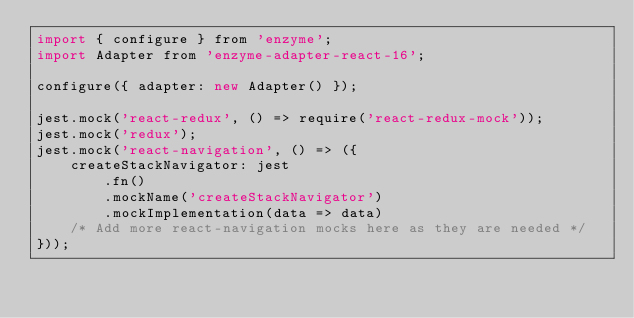<code> <loc_0><loc_0><loc_500><loc_500><_JavaScript_>import { configure } from 'enzyme';
import Adapter from 'enzyme-adapter-react-16';

configure({ adapter: new Adapter() });

jest.mock('react-redux', () => require('react-redux-mock'));
jest.mock('redux');
jest.mock('react-navigation', () => ({
    createStackNavigator: jest
        .fn()
        .mockName('createStackNavigator')
        .mockImplementation(data => data)
    /* Add more react-navigation mocks here as they are needed */
}));
</code> 